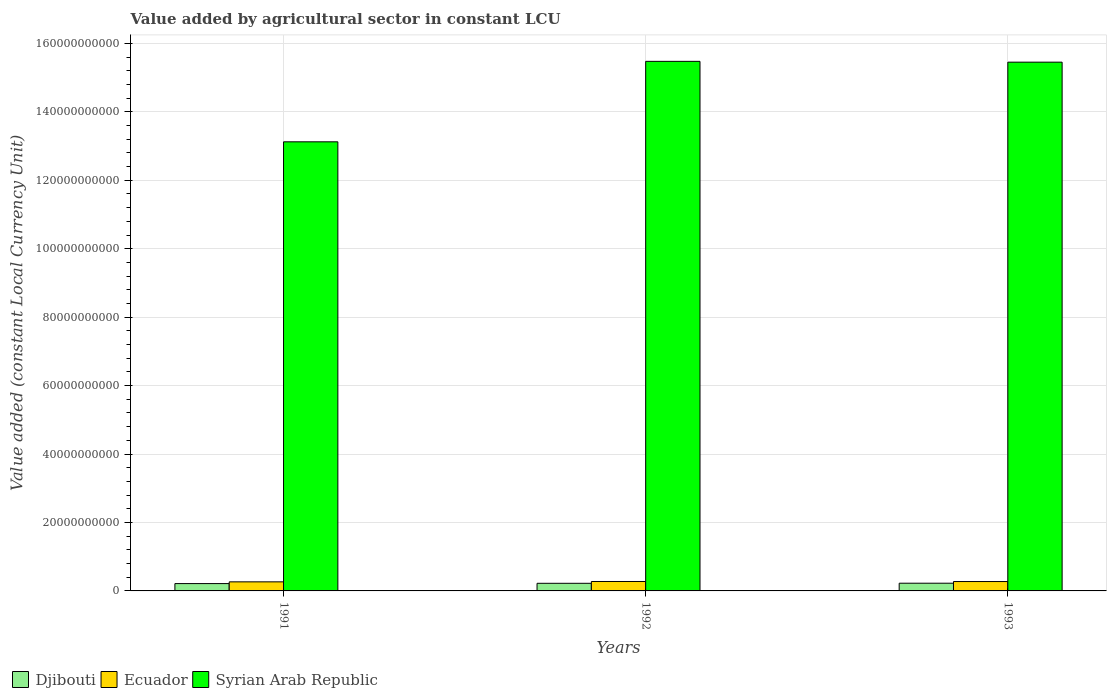How many groups of bars are there?
Your response must be concise. 3. How many bars are there on the 2nd tick from the left?
Keep it short and to the point. 3. In how many cases, is the number of bars for a given year not equal to the number of legend labels?
Provide a succinct answer. 0. What is the value added by agricultural sector in Djibouti in 1991?
Make the answer very short. 2.14e+09. Across all years, what is the maximum value added by agricultural sector in Djibouti?
Give a very brief answer. 2.25e+09. Across all years, what is the minimum value added by agricultural sector in Djibouti?
Make the answer very short. 2.14e+09. In which year was the value added by agricultural sector in Djibouti maximum?
Offer a terse response. 1993. What is the total value added by agricultural sector in Djibouti in the graph?
Ensure brevity in your answer.  6.62e+09. What is the difference between the value added by agricultural sector in Djibouti in 1991 and that in 1992?
Provide a succinct answer. -8.37e+07. What is the difference between the value added by agricultural sector in Ecuador in 1992 and the value added by agricultural sector in Djibouti in 1993?
Ensure brevity in your answer.  5.07e+08. What is the average value added by agricultural sector in Syrian Arab Republic per year?
Give a very brief answer. 1.47e+11. In the year 1992, what is the difference between the value added by agricultural sector in Djibouti and value added by agricultural sector in Ecuador?
Offer a terse response. -5.30e+08. What is the ratio of the value added by agricultural sector in Syrian Arab Republic in 1991 to that in 1992?
Provide a succinct answer. 0.85. What is the difference between the highest and the second highest value added by agricultural sector in Ecuador?
Ensure brevity in your answer.  1.37e+07. What is the difference between the highest and the lowest value added by agricultural sector in Syrian Arab Republic?
Offer a very short reply. 2.35e+1. In how many years, is the value added by agricultural sector in Ecuador greater than the average value added by agricultural sector in Ecuador taken over all years?
Offer a terse response. 2. What does the 3rd bar from the left in 1993 represents?
Your response must be concise. Syrian Arab Republic. What does the 2nd bar from the right in 1991 represents?
Give a very brief answer. Ecuador. Is it the case that in every year, the sum of the value added by agricultural sector in Ecuador and value added by agricultural sector in Djibouti is greater than the value added by agricultural sector in Syrian Arab Republic?
Offer a terse response. No. Are all the bars in the graph horizontal?
Provide a short and direct response. No. What is the difference between two consecutive major ticks on the Y-axis?
Your answer should be compact. 2.00e+1. Does the graph contain any zero values?
Your response must be concise. No. Does the graph contain grids?
Your answer should be very brief. Yes. How many legend labels are there?
Ensure brevity in your answer.  3. What is the title of the graph?
Provide a short and direct response. Value added by agricultural sector in constant LCU. What is the label or title of the Y-axis?
Your answer should be compact. Value added (constant Local Currency Unit). What is the Value added (constant Local Currency Unit) in Djibouti in 1991?
Provide a succinct answer. 2.14e+09. What is the Value added (constant Local Currency Unit) of Ecuador in 1991?
Give a very brief answer. 2.65e+09. What is the Value added (constant Local Currency Unit) in Syrian Arab Republic in 1991?
Your response must be concise. 1.31e+11. What is the Value added (constant Local Currency Unit) of Djibouti in 1992?
Your response must be concise. 2.23e+09. What is the Value added (constant Local Currency Unit) of Ecuador in 1992?
Provide a succinct answer. 2.76e+09. What is the Value added (constant Local Currency Unit) of Syrian Arab Republic in 1992?
Your response must be concise. 1.55e+11. What is the Value added (constant Local Currency Unit) in Djibouti in 1993?
Keep it short and to the point. 2.25e+09. What is the Value added (constant Local Currency Unit) in Ecuador in 1993?
Ensure brevity in your answer.  2.74e+09. What is the Value added (constant Local Currency Unit) in Syrian Arab Republic in 1993?
Offer a terse response. 1.55e+11. Across all years, what is the maximum Value added (constant Local Currency Unit) of Djibouti?
Ensure brevity in your answer.  2.25e+09. Across all years, what is the maximum Value added (constant Local Currency Unit) in Ecuador?
Provide a succinct answer. 2.76e+09. Across all years, what is the maximum Value added (constant Local Currency Unit) of Syrian Arab Republic?
Ensure brevity in your answer.  1.55e+11. Across all years, what is the minimum Value added (constant Local Currency Unit) of Djibouti?
Make the answer very short. 2.14e+09. Across all years, what is the minimum Value added (constant Local Currency Unit) of Ecuador?
Provide a succinct answer. 2.65e+09. Across all years, what is the minimum Value added (constant Local Currency Unit) of Syrian Arab Republic?
Provide a succinct answer. 1.31e+11. What is the total Value added (constant Local Currency Unit) in Djibouti in the graph?
Provide a succinct answer. 6.62e+09. What is the total Value added (constant Local Currency Unit) of Ecuador in the graph?
Your response must be concise. 8.15e+09. What is the total Value added (constant Local Currency Unit) in Syrian Arab Republic in the graph?
Your answer should be very brief. 4.41e+11. What is the difference between the Value added (constant Local Currency Unit) of Djibouti in 1991 and that in 1992?
Your response must be concise. -8.37e+07. What is the difference between the Value added (constant Local Currency Unit) in Ecuador in 1991 and that in 1992?
Ensure brevity in your answer.  -1.07e+08. What is the difference between the Value added (constant Local Currency Unit) of Syrian Arab Republic in 1991 and that in 1992?
Ensure brevity in your answer.  -2.35e+1. What is the difference between the Value added (constant Local Currency Unit) in Djibouti in 1991 and that in 1993?
Make the answer very short. -1.07e+08. What is the difference between the Value added (constant Local Currency Unit) in Ecuador in 1991 and that in 1993?
Ensure brevity in your answer.  -9.29e+07. What is the difference between the Value added (constant Local Currency Unit) in Syrian Arab Republic in 1991 and that in 1993?
Your answer should be very brief. -2.33e+1. What is the difference between the Value added (constant Local Currency Unit) in Djibouti in 1992 and that in 1993?
Make the answer very short. -2.35e+07. What is the difference between the Value added (constant Local Currency Unit) in Ecuador in 1992 and that in 1993?
Provide a short and direct response. 1.37e+07. What is the difference between the Value added (constant Local Currency Unit) in Syrian Arab Republic in 1992 and that in 1993?
Offer a terse response. 2.36e+08. What is the difference between the Value added (constant Local Currency Unit) in Djibouti in 1991 and the Value added (constant Local Currency Unit) in Ecuador in 1992?
Ensure brevity in your answer.  -6.14e+08. What is the difference between the Value added (constant Local Currency Unit) in Djibouti in 1991 and the Value added (constant Local Currency Unit) in Syrian Arab Republic in 1992?
Your response must be concise. -1.53e+11. What is the difference between the Value added (constant Local Currency Unit) in Ecuador in 1991 and the Value added (constant Local Currency Unit) in Syrian Arab Republic in 1992?
Make the answer very short. -1.52e+11. What is the difference between the Value added (constant Local Currency Unit) of Djibouti in 1991 and the Value added (constant Local Currency Unit) of Ecuador in 1993?
Your response must be concise. -6.00e+08. What is the difference between the Value added (constant Local Currency Unit) of Djibouti in 1991 and the Value added (constant Local Currency Unit) of Syrian Arab Republic in 1993?
Provide a succinct answer. -1.52e+11. What is the difference between the Value added (constant Local Currency Unit) of Ecuador in 1991 and the Value added (constant Local Currency Unit) of Syrian Arab Republic in 1993?
Keep it short and to the point. -1.52e+11. What is the difference between the Value added (constant Local Currency Unit) in Djibouti in 1992 and the Value added (constant Local Currency Unit) in Ecuador in 1993?
Your answer should be compact. -5.16e+08. What is the difference between the Value added (constant Local Currency Unit) in Djibouti in 1992 and the Value added (constant Local Currency Unit) in Syrian Arab Republic in 1993?
Offer a terse response. -1.52e+11. What is the difference between the Value added (constant Local Currency Unit) in Ecuador in 1992 and the Value added (constant Local Currency Unit) in Syrian Arab Republic in 1993?
Ensure brevity in your answer.  -1.52e+11. What is the average Value added (constant Local Currency Unit) of Djibouti per year?
Provide a succinct answer. 2.21e+09. What is the average Value added (constant Local Currency Unit) in Ecuador per year?
Offer a very short reply. 2.72e+09. What is the average Value added (constant Local Currency Unit) in Syrian Arab Republic per year?
Give a very brief answer. 1.47e+11. In the year 1991, what is the difference between the Value added (constant Local Currency Unit) in Djibouti and Value added (constant Local Currency Unit) in Ecuador?
Offer a very short reply. -5.07e+08. In the year 1991, what is the difference between the Value added (constant Local Currency Unit) in Djibouti and Value added (constant Local Currency Unit) in Syrian Arab Republic?
Keep it short and to the point. -1.29e+11. In the year 1991, what is the difference between the Value added (constant Local Currency Unit) of Ecuador and Value added (constant Local Currency Unit) of Syrian Arab Republic?
Provide a short and direct response. -1.29e+11. In the year 1992, what is the difference between the Value added (constant Local Currency Unit) of Djibouti and Value added (constant Local Currency Unit) of Ecuador?
Ensure brevity in your answer.  -5.30e+08. In the year 1992, what is the difference between the Value added (constant Local Currency Unit) in Djibouti and Value added (constant Local Currency Unit) in Syrian Arab Republic?
Keep it short and to the point. -1.53e+11. In the year 1992, what is the difference between the Value added (constant Local Currency Unit) in Ecuador and Value added (constant Local Currency Unit) in Syrian Arab Republic?
Keep it short and to the point. -1.52e+11. In the year 1993, what is the difference between the Value added (constant Local Currency Unit) in Djibouti and Value added (constant Local Currency Unit) in Ecuador?
Ensure brevity in your answer.  -4.93e+08. In the year 1993, what is the difference between the Value added (constant Local Currency Unit) in Djibouti and Value added (constant Local Currency Unit) in Syrian Arab Republic?
Offer a very short reply. -1.52e+11. In the year 1993, what is the difference between the Value added (constant Local Currency Unit) in Ecuador and Value added (constant Local Currency Unit) in Syrian Arab Republic?
Your response must be concise. -1.52e+11. What is the ratio of the Value added (constant Local Currency Unit) of Djibouti in 1991 to that in 1992?
Make the answer very short. 0.96. What is the ratio of the Value added (constant Local Currency Unit) in Ecuador in 1991 to that in 1992?
Your answer should be compact. 0.96. What is the ratio of the Value added (constant Local Currency Unit) in Syrian Arab Republic in 1991 to that in 1992?
Your answer should be compact. 0.85. What is the ratio of the Value added (constant Local Currency Unit) in Djibouti in 1991 to that in 1993?
Give a very brief answer. 0.95. What is the ratio of the Value added (constant Local Currency Unit) in Ecuador in 1991 to that in 1993?
Your answer should be very brief. 0.97. What is the ratio of the Value added (constant Local Currency Unit) of Syrian Arab Republic in 1991 to that in 1993?
Your response must be concise. 0.85. What is the ratio of the Value added (constant Local Currency Unit) of Djibouti in 1992 to that in 1993?
Give a very brief answer. 0.99. What is the ratio of the Value added (constant Local Currency Unit) of Syrian Arab Republic in 1992 to that in 1993?
Ensure brevity in your answer.  1. What is the difference between the highest and the second highest Value added (constant Local Currency Unit) of Djibouti?
Provide a short and direct response. 2.35e+07. What is the difference between the highest and the second highest Value added (constant Local Currency Unit) of Ecuador?
Make the answer very short. 1.37e+07. What is the difference between the highest and the second highest Value added (constant Local Currency Unit) of Syrian Arab Republic?
Provide a short and direct response. 2.36e+08. What is the difference between the highest and the lowest Value added (constant Local Currency Unit) of Djibouti?
Your response must be concise. 1.07e+08. What is the difference between the highest and the lowest Value added (constant Local Currency Unit) of Ecuador?
Offer a terse response. 1.07e+08. What is the difference between the highest and the lowest Value added (constant Local Currency Unit) of Syrian Arab Republic?
Offer a very short reply. 2.35e+1. 